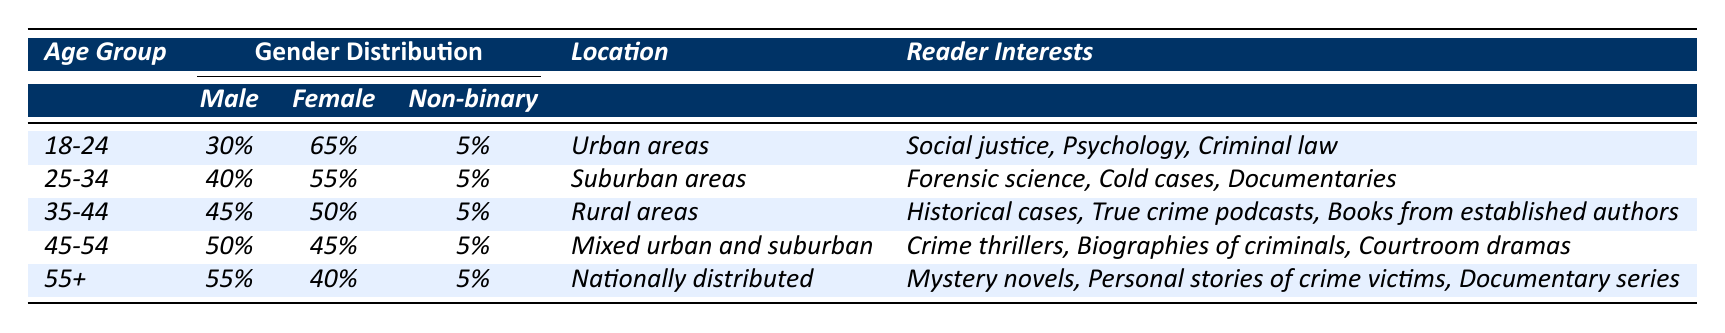What is the gender distribution of the age group 18-24? According to the table, for the age group 18-24, the gender distribution is 30% male, 65% female, and 5% non-binary.
Answer: 30% male, 65% female, 5% non-binary Which age group has the highest percentage of male readers? By examining the table, the age group 55+ has the highest percentage of male readers, with 55%.
Answer: 55+ Are the majority of true crime readers aged 35-44 male? In the age group 35-44, the table shows 45% male, which is not the majority since more than 50% would be needed.
Answer: No What percentage of female readers is there in the age group 45-54? The table indicates that for the age group 45-54, the percentage of female readers is 45%.
Answer: 45% How many age groups have a non-binary percentage of 5%? Each of the age groups listed in the table shows a non-binary percentage of 5%, and there are five age groups in total.
Answer: 5 age groups If we consider only the male and female reader percentages, which age group has the closest gender balance? In the age group 35-44, the percentage is 45% male and 50% female, which means the difference is only 5%. This is the closest among all groups.
Answer: Age group 35-44 Which age group reads about "true crime podcasts" as a primary interest? The age group 35-44 has "True crime podcasts" listed under their reader interests according to the table.
Answer: Age group 35-44 Combined, what is the total percentage of female readers across all age groups? The female percentages from the table are 65%, 55%, 50%, 45%, and 40%. Adding them gives 65 + 55 + 50 + 45 + 40 = 255%, so the total percentage of female readers is 255%.
Answer: 255% In which location do most readers aged 25-34 reside? The table shows that readers aged 25-34 primarily reside in suburban areas such as Chicago and Seattle.
Answer: Suburban areas Is there any age group with an equal distribution of male and female readers? No age group has an equal distribution as the closest is 35-44 with 45% male and 50% female.
Answer: No 